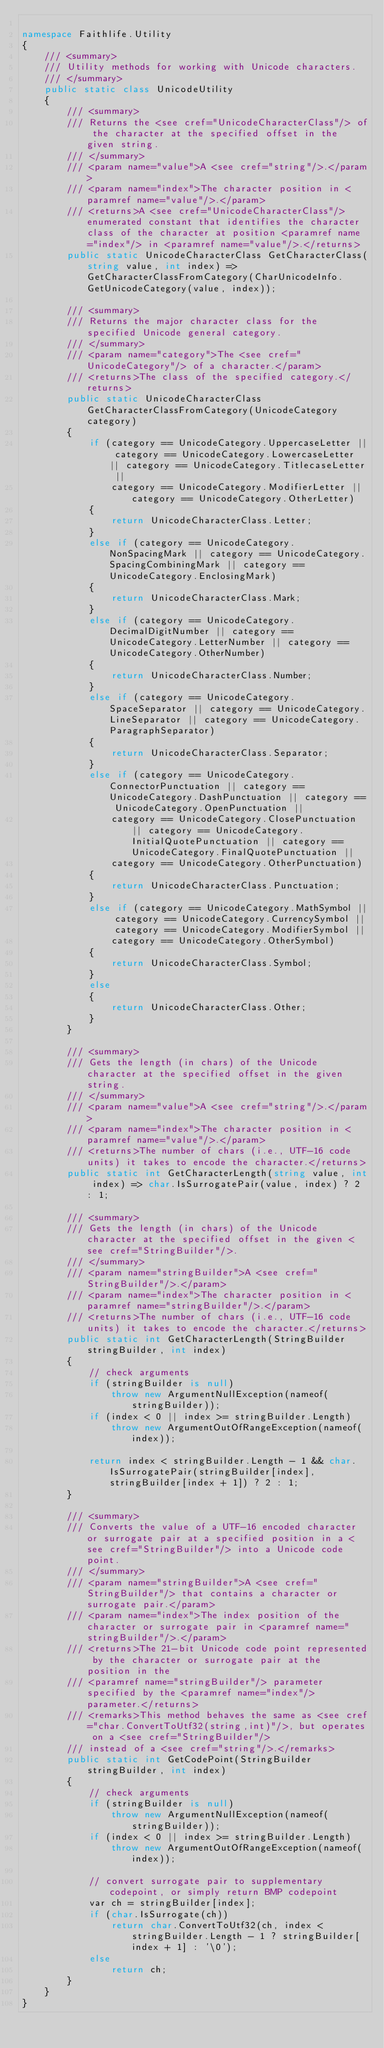<code> <loc_0><loc_0><loc_500><loc_500><_C#_>
namespace Faithlife.Utility
{
	/// <summary>
	/// Utility methods for working with Unicode characters.
	/// </summary>
	public static class UnicodeUtility
	{
		/// <summary>
		/// Returns the <see cref="UnicodeCharacterClass"/> of the character at the specified offset in the given string.
		/// </summary>
		/// <param name="value">A <see cref="string"/>.</param>
		/// <param name="index">The character position in <paramref name="value"/>.</param>
		/// <returns>A <see cref="UnicodeCharacterClass"/> enumerated constant that identifies the character class of the character at position <paramref name="index"/> in <paramref name="value"/>.</returns>
		public static UnicodeCharacterClass GetCharacterClass(string value, int index) => GetCharacterClassFromCategory(CharUnicodeInfo.GetUnicodeCategory(value, index));

		/// <summary>
		/// Returns the major character class for the specified Unicode general category.
		/// </summary>
		/// <param name="category">The <see cref="UnicodeCategory"/> of a character.</param>
		/// <returns>The class of the specified category.</returns>
		public static UnicodeCharacterClass GetCharacterClassFromCategory(UnicodeCategory category)
		{
			if (category == UnicodeCategory.UppercaseLetter || category == UnicodeCategory.LowercaseLetter || category == UnicodeCategory.TitlecaseLetter ||
				category == UnicodeCategory.ModifierLetter || category == UnicodeCategory.OtherLetter)
			{
				return UnicodeCharacterClass.Letter;
			}
			else if (category == UnicodeCategory.NonSpacingMark || category == UnicodeCategory.SpacingCombiningMark || category == UnicodeCategory.EnclosingMark)
			{
				return UnicodeCharacterClass.Mark;
			}
			else if (category == UnicodeCategory.DecimalDigitNumber || category == UnicodeCategory.LetterNumber || category == UnicodeCategory.OtherNumber)
			{
				return UnicodeCharacterClass.Number;
			}
			else if (category == UnicodeCategory.SpaceSeparator || category == UnicodeCategory.LineSeparator || category == UnicodeCategory.ParagraphSeparator)
			{
				return UnicodeCharacterClass.Separator;
			}
			else if (category == UnicodeCategory.ConnectorPunctuation || category == UnicodeCategory.DashPunctuation || category == UnicodeCategory.OpenPunctuation ||
				category == UnicodeCategory.ClosePunctuation || category == UnicodeCategory.InitialQuotePunctuation || category == UnicodeCategory.FinalQuotePunctuation ||
				category == UnicodeCategory.OtherPunctuation)
			{
				return UnicodeCharacterClass.Punctuation;
			}
			else if (category == UnicodeCategory.MathSymbol || category == UnicodeCategory.CurrencySymbol || category == UnicodeCategory.ModifierSymbol ||
				category == UnicodeCategory.OtherSymbol)
			{
				return UnicodeCharacterClass.Symbol;
			}
			else
			{
				return UnicodeCharacterClass.Other;
			}
		}

		/// <summary>
		/// Gets the length (in chars) of the Unicode character at the specified offset in the given string.
		/// </summary>
		/// <param name="value">A <see cref="string"/>.</param>
		/// <param name="index">The character position in <paramref name="value"/>.</param>
		/// <returns>The number of chars (i.e., UTF-16 code units) it takes to encode the character.</returns>
		public static int GetCharacterLength(string value, int index) => char.IsSurrogatePair(value, index) ? 2 : 1;

		/// <summary>
		/// Gets the length (in chars) of the Unicode character at the specified offset in the given <see cref="StringBuilder"/>.
		/// </summary>
		/// <param name="stringBuilder">A <see cref="StringBuilder"/>.</param>
		/// <param name="index">The character position in <paramref name="stringBuilder"/>.</param>
		/// <returns>The number of chars (i.e., UTF-16 code units) it takes to encode the character.</returns>
		public static int GetCharacterLength(StringBuilder stringBuilder, int index)
		{
			// check arguments
			if (stringBuilder is null)
				throw new ArgumentNullException(nameof(stringBuilder));
			if (index < 0 || index >= stringBuilder.Length)
				throw new ArgumentOutOfRangeException(nameof(index));

			return index < stringBuilder.Length - 1 && char.IsSurrogatePair(stringBuilder[index], stringBuilder[index + 1]) ? 2 : 1;
		}

		/// <summary>
		/// Converts the value of a UTF-16 encoded character or surrogate pair at a specified position in a <see cref="StringBuilder"/> into a Unicode code point.
		/// </summary>
		/// <param name="stringBuilder">A <see cref="StringBuilder"/> that contains a character or surrogate pair.</param>
		/// <param name="index">The index position of the character or surrogate pair in <paramref name="stringBuilder"/>.</param>
		/// <returns>The 21-bit Unicode code point represented by the character or surrogate pair at the position in the
		/// <paramref name="stringBuilder"/> parameter specified by the <paramref name="index"/> parameter.</returns>
		/// <remarks>This method behaves the same as <see cref="char.ConvertToUtf32(string,int)"/>, but operates on a <see cref="StringBuilder"/>
		/// instead of a <see cref="string"/>.</remarks>
		public static int GetCodePoint(StringBuilder stringBuilder, int index)
		{
			// check arguments
			if (stringBuilder is null)
				throw new ArgumentNullException(nameof(stringBuilder));
			if (index < 0 || index >= stringBuilder.Length)
				throw new ArgumentOutOfRangeException(nameof(index));

			// convert surrogate pair to supplementary codepoint, or simply return BMP codepoint
			var ch = stringBuilder[index];
			if (char.IsSurrogate(ch))
				return char.ConvertToUtf32(ch, index < stringBuilder.Length - 1 ? stringBuilder[index + 1] : '\0');
			else
				return ch;
		}
	}
}
</code> 